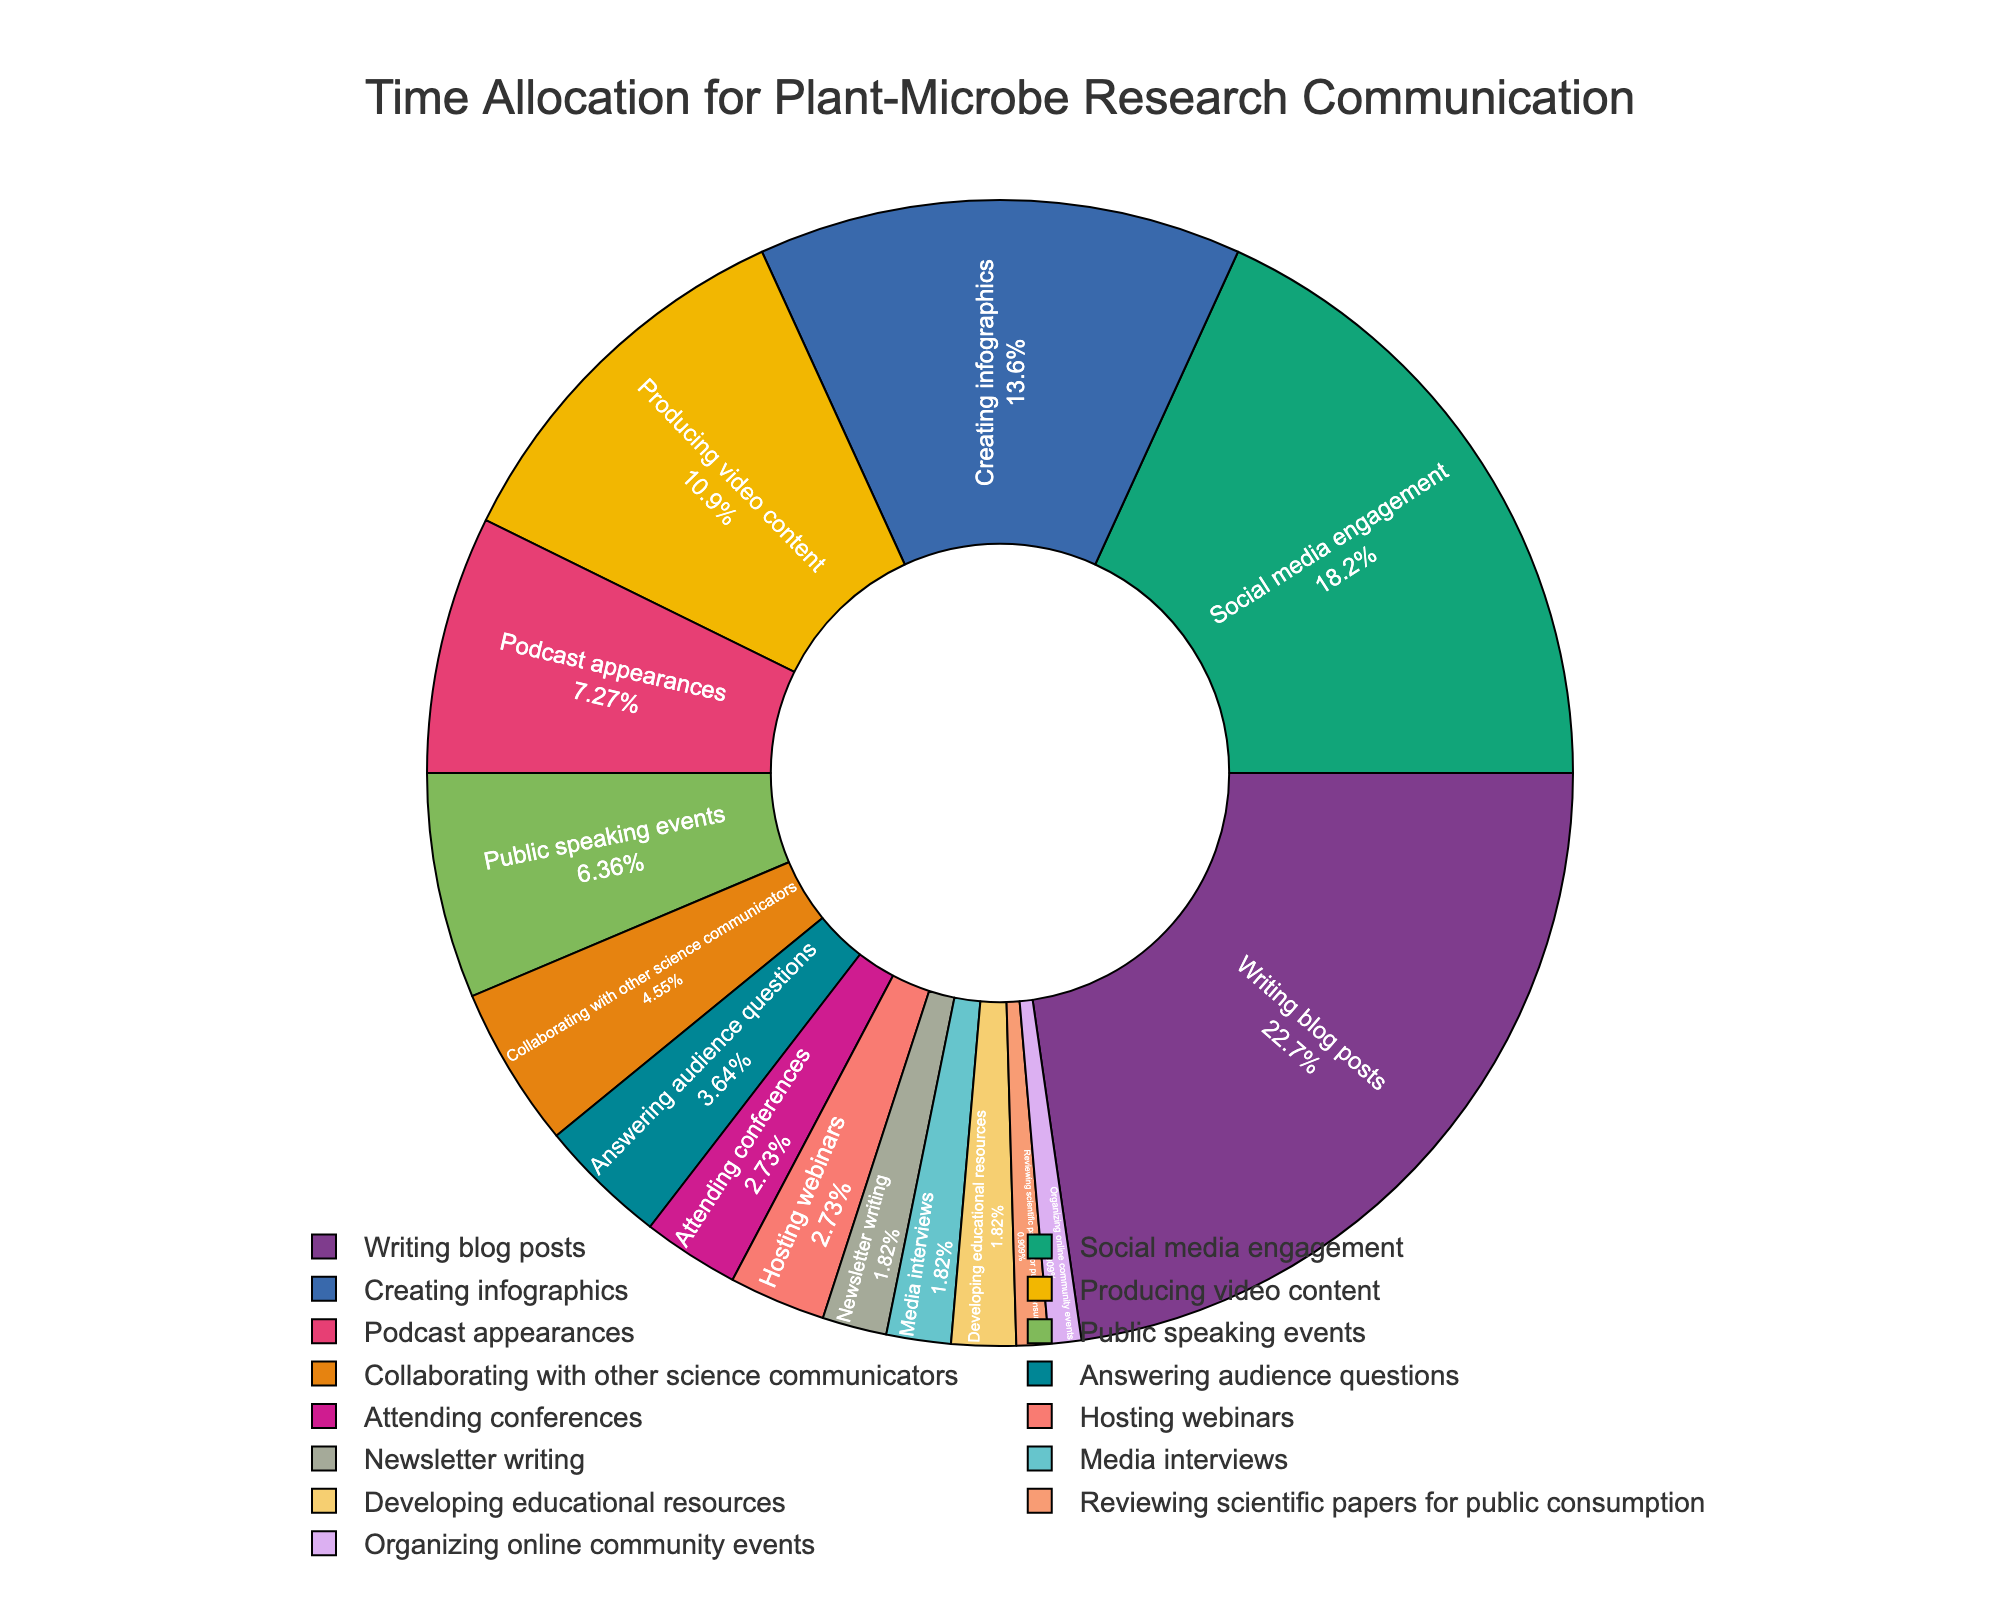What activity takes up the largest portion of time for science communication? Referring to the pie chart, the activity with the largest segment is "Writing blog posts" at 25%.
Answer: Writing blog posts What is the combined percentage of time spent on "Public speaking events", "Collaborating with other science communicators", and "Answering audience questions"? Add the percentages for each activity: 7% (Public speaking events) + 5% (Collaborating with other science communicators) + 4% (Answering audience questions) = 16%.
Answer: 16% Which takes up more time, "Producing video content" or "Creating infographics"? According to the chart, "Producing video content" is 12% and "Creating infographics" is 15%, so creating infographics takes up more time.
Answer: Creating infographics How much time is allocated to activities that involve direct interaction with an audience, such as answering questions and hosting webinars? Sum the percentages for "Answering audience questions" (4%) and "Hosting webinars" (3%) which gives 4% + 3% = 7%.
Answer: 7% Compare the time spent on "Social media engagement" and "Podcast appearances". Which one is higher and by how much? "Social media engagement" is 20% and "Podcast appearances" is 8%. The difference is 20% - 8% = 12%.
Answer: Social media engagement by 12% What three activities take up the least amount of time and how much time do they collectively account for? The three activities with the smallest segments are "Reviewing scientific papers for public consumption" (1%), "Organizing online community events" (1%), and "Newsletter writing" (2%). Together, they total 1% + 1% + 2% = 4%.
Answer: Reviewing scientific papers for public consumption, Organizing online community events, and Newsletter writing; 4% What is the percentage difference between the time spent on "Writing blog posts" and "Social media engagement"? "Writing blog posts" accounts for 25%, "Social media engagement" is 20%. The difference is 25% - 20% = 5%.
Answer: 5% Which activity had a visual representation with text information inside the segment? Each segment on the pie chart has text information inside it, indicating the percentage and activity.
Answer: All activities How does the time spent on "Attending conferences" compare to "Hosting webinars"? Both "Attending conferences" and "Hosting webinars" have the same allocation of 3%.
Answer: Equal What proportion of time is dedicated to media activities, including media interviews and podcast appearances? Add the percentages: "Media interviews" is 2%, and "Podcast appearances" is 8%; thus, the total is 2% + 8% = 10%.
Answer: 10% 